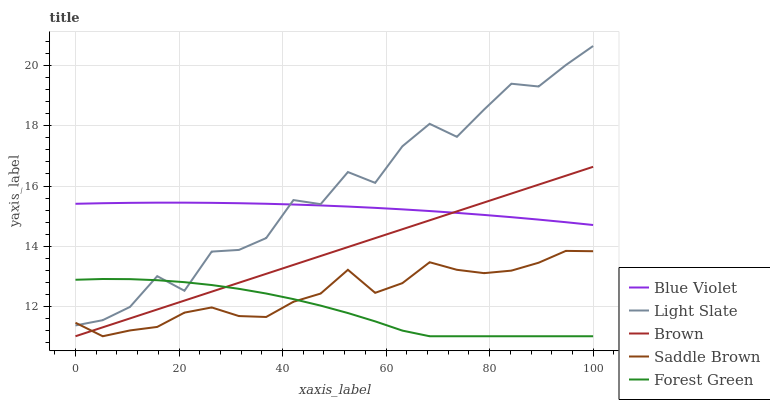Does Forest Green have the minimum area under the curve?
Answer yes or no. Yes. Does Light Slate have the maximum area under the curve?
Answer yes or no. Yes. Does Brown have the minimum area under the curve?
Answer yes or no. No. Does Brown have the maximum area under the curve?
Answer yes or no. No. Is Brown the smoothest?
Answer yes or no. Yes. Is Light Slate the roughest?
Answer yes or no. Yes. Is Forest Green the smoothest?
Answer yes or no. No. Is Forest Green the roughest?
Answer yes or no. No. Does Brown have the lowest value?
Answer yes or no. Yes. Does Blue Violet have the lowest value?
Answer yes or no. No. Does Light Slate have the highest value?
Answer yes or no. Yes. Does Brown have the highest value?
Answer yes or no. No. Is Forest Green less than Blue Violet?
Answer yes or no. Yes. Is Blue Violet greater than Forest Green?
Answer yes or no. Yes. Does Brown intersect Saddle Brown?
Answer yes or no. Yes. Is Brown less than Saddle Brown?
Answer yes or no. No. Is Brown greater than Saddle Brown?
Answer yes or no. No. Does Forest Green intersect Blue Violet?
Answer yes or no. No. 